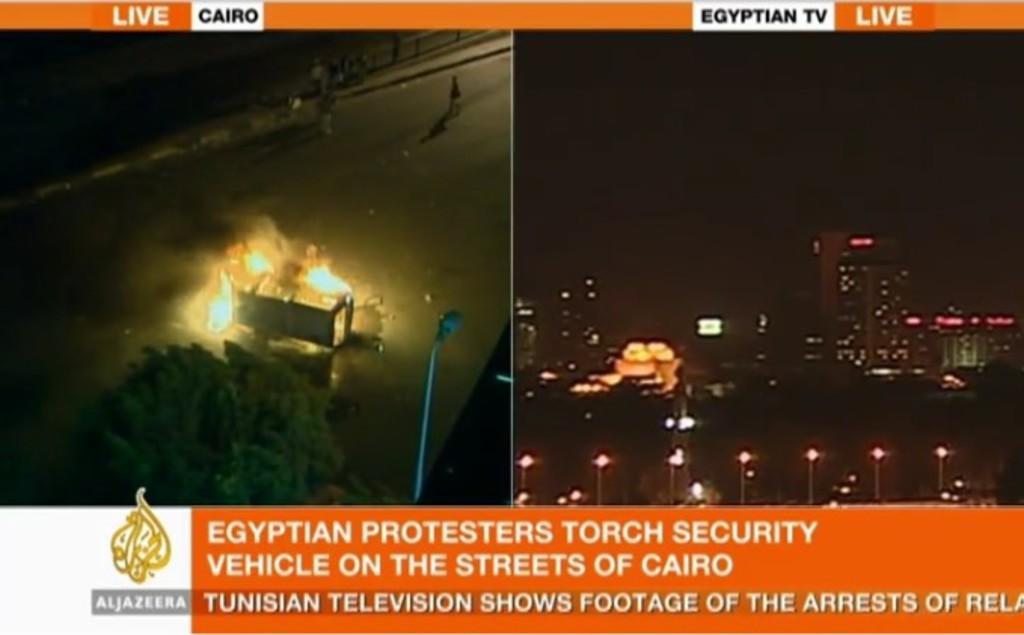Can you describe this image briefly? In this image we can see some text here. This picture is taken in dark where we can see an object is with fire, we can see tree and the light pole. This picture is taken in dark where we can see buildings. 